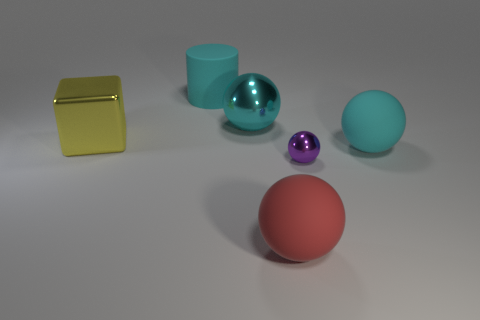Are there any other things that are the same size as the purple metal thing?
Offer a very short reply. No. What is the size of the ball that is both in front of the cyan shiny ball and behind the tiny purple ball?
Your answer should be compact. Large. The big rubber object that is the same color as the large matte cylinder is what shape?
Give a very brief answer. Sphere. The large cube is what color?
Provide a short and direct response. Yellow. What is the size of the object on the left side of the matte cylinder?
Offer a terse response. Large. What number of tiny shiny balls are in front of the big matte cylinder that is on the left side of the big object that is in front of the purple shiny object?
Provide a short and direct response. 1. There is a big matte object behind the cyan matte thing in front of the big cyan metal sphere; what color is it?
Your answer should be very brief. Cyan. Is there a purple shiny object of the same size as the rubber cylinder?
Offer a very short reply. No. What material is the large sphere that is to the right of the large rubber thing in front of the large cyan rubber object on the right side of the tiny purple object?
Give a very brief answer. Rubber. How many red things are left of the big cyan sphere in front of the big cube?
Provide a short and direct response. 1. 